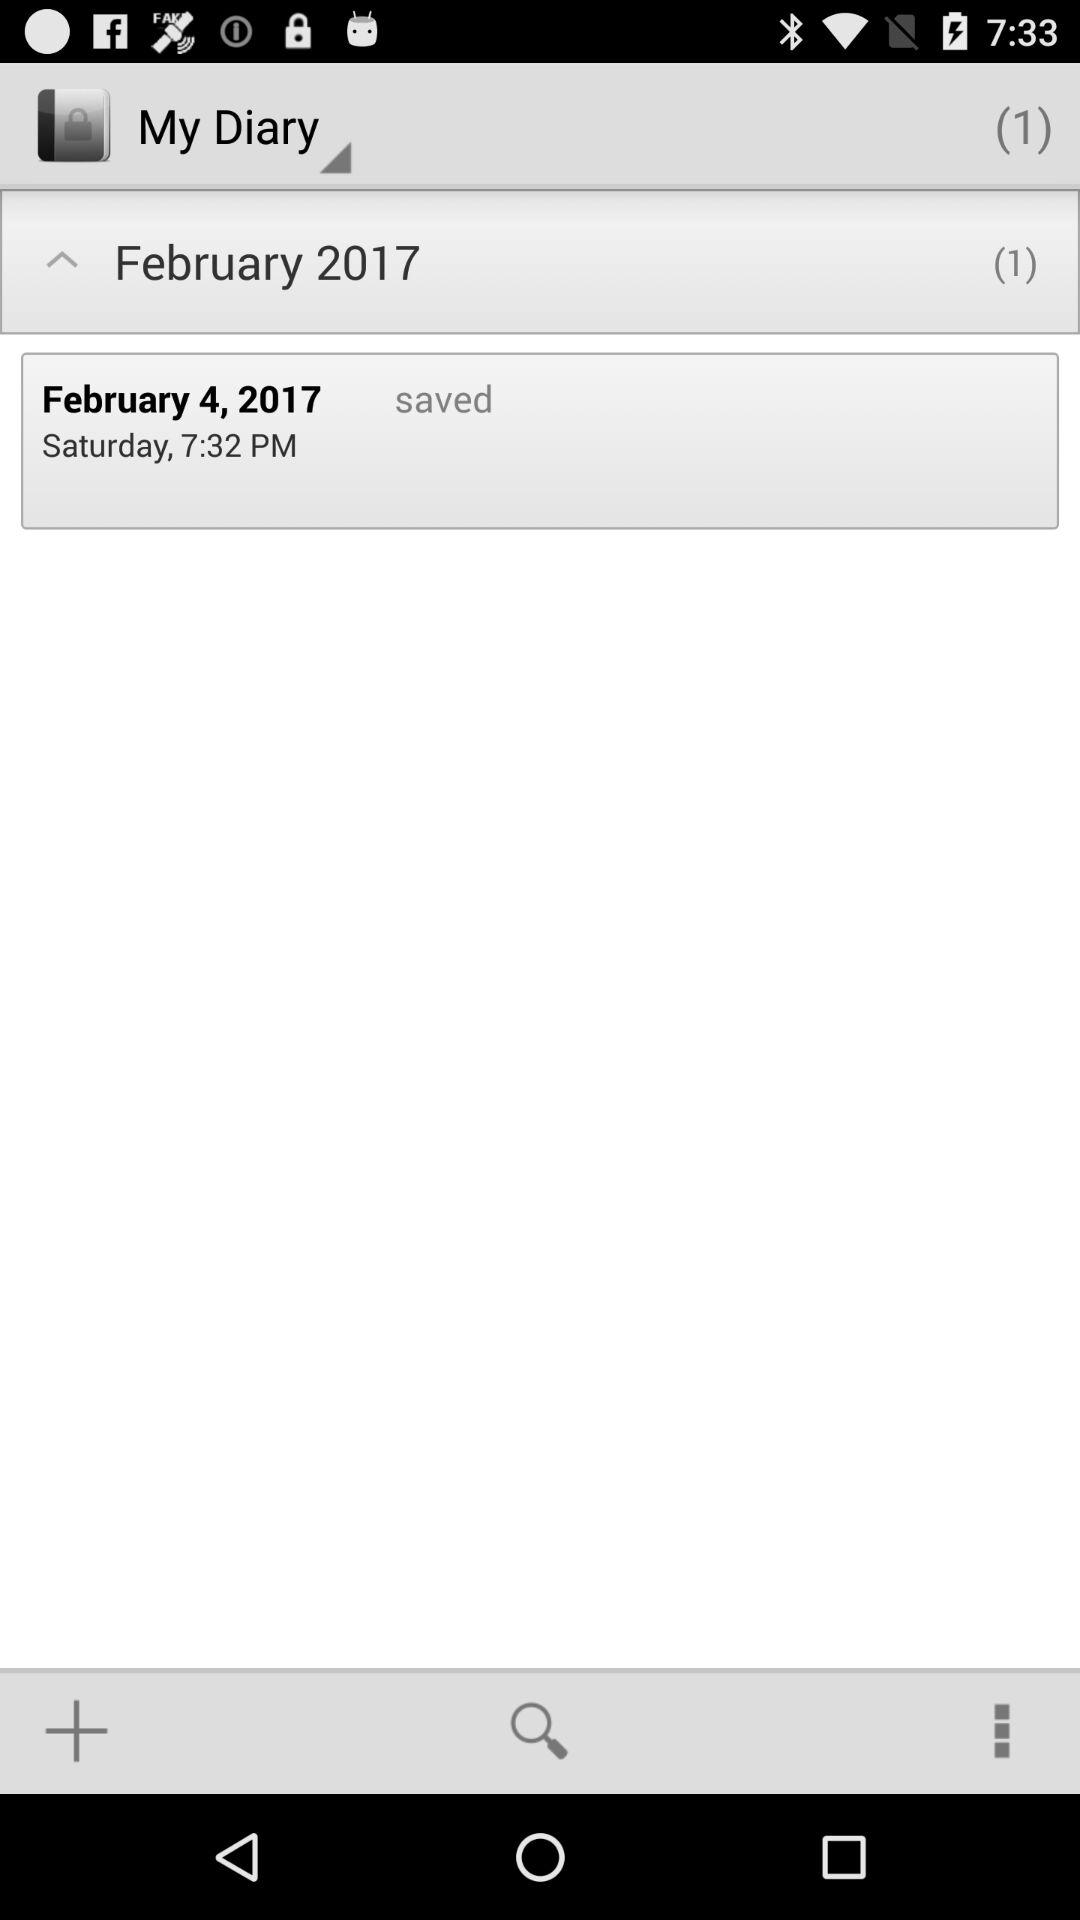On what date was the note saved in the "My Diary" section of the application? The note was saved on Saturday, February 4, 2017. 